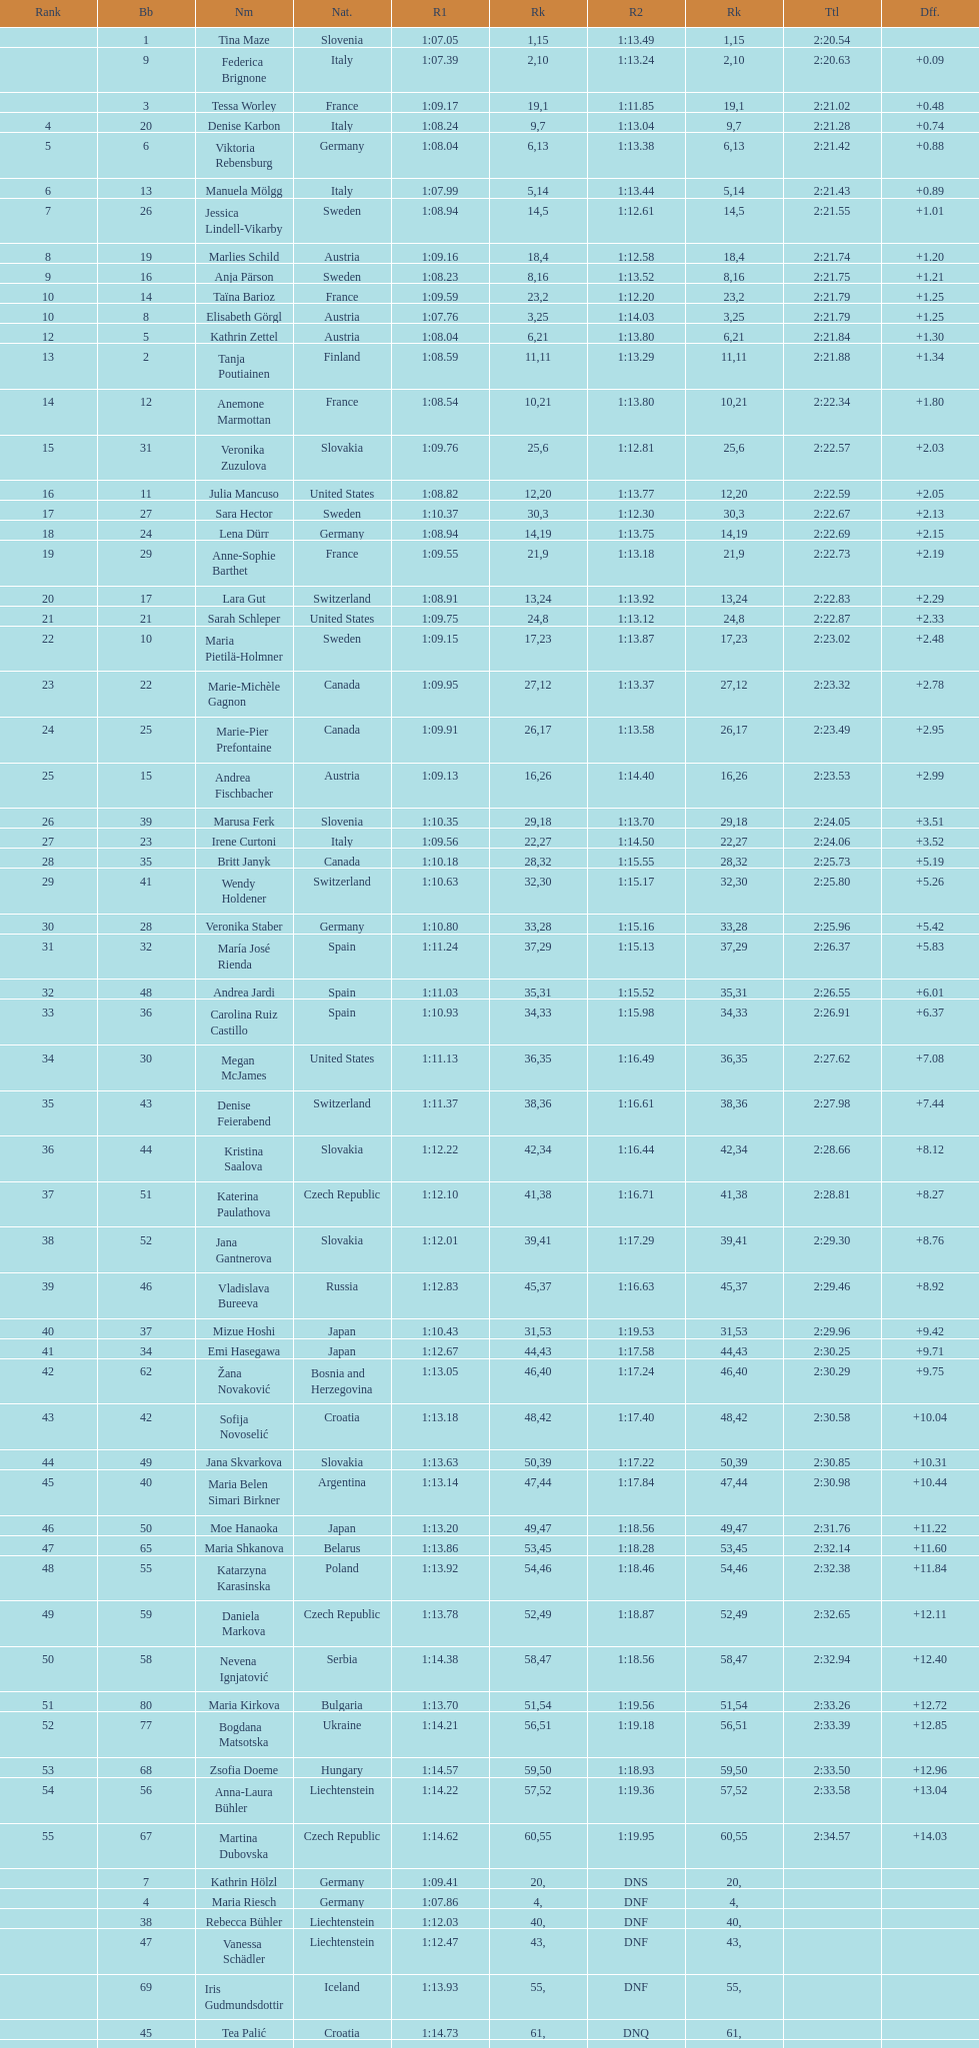What is the last nation to be ranked? Czech Republic. 